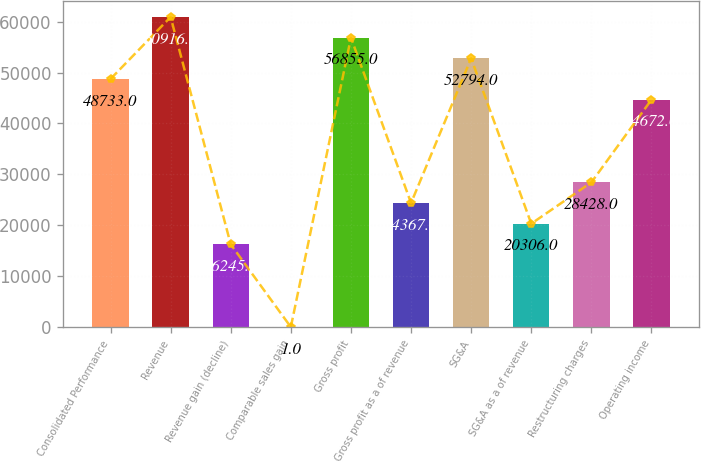Convert chart. <chart><loc_0><loc_0><loc_500><loc_500><bar_chart><fcel>Consolidated Performance<fcel>Revenue<fcel>Revenue gain (decline)<fcel>Comparable sales gain<fcel>Gross profit<fcel>Gross profit as a of revenue<fcel>SG&A<fcel>SG&A as a of revenue<fcel>Restructuring charges<fcel>Operating income<nl><fcel>48733<fcel>60916<fcel>16245<fcel>1<fcel>56855<fcel>24367<fcel>52794<fcel>20306<fcel>28428<fcel>44672<nl></chart> 